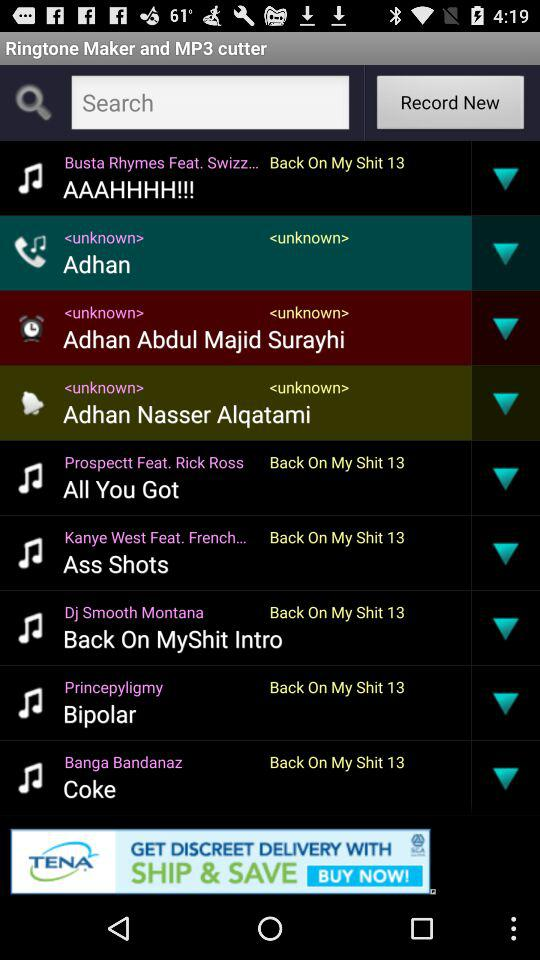Who's the singer of "All You Got"? The singer is "Rick Ross". 